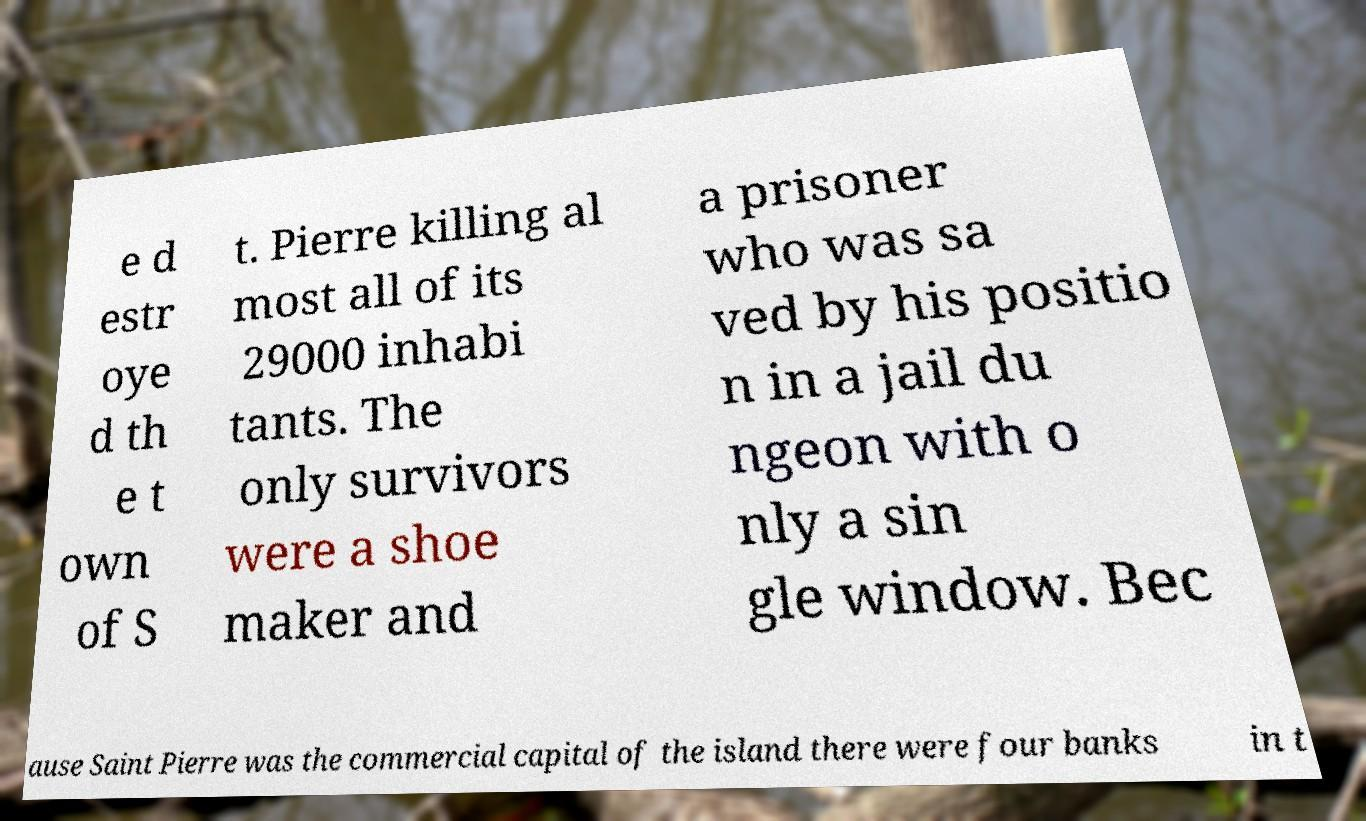Please identify and transcribe the text found in this image. e d estr oye d th e t own of S t. Pierre killing al most all of its 29000 inhabi tants. The only survivors were a shoe maker and a prisoner who was sa ved by his positio n in a jail du ngeon with o nly a sin gle window. Bec ause Saint Pierre was the commercial capital of the island there were four banks in t 